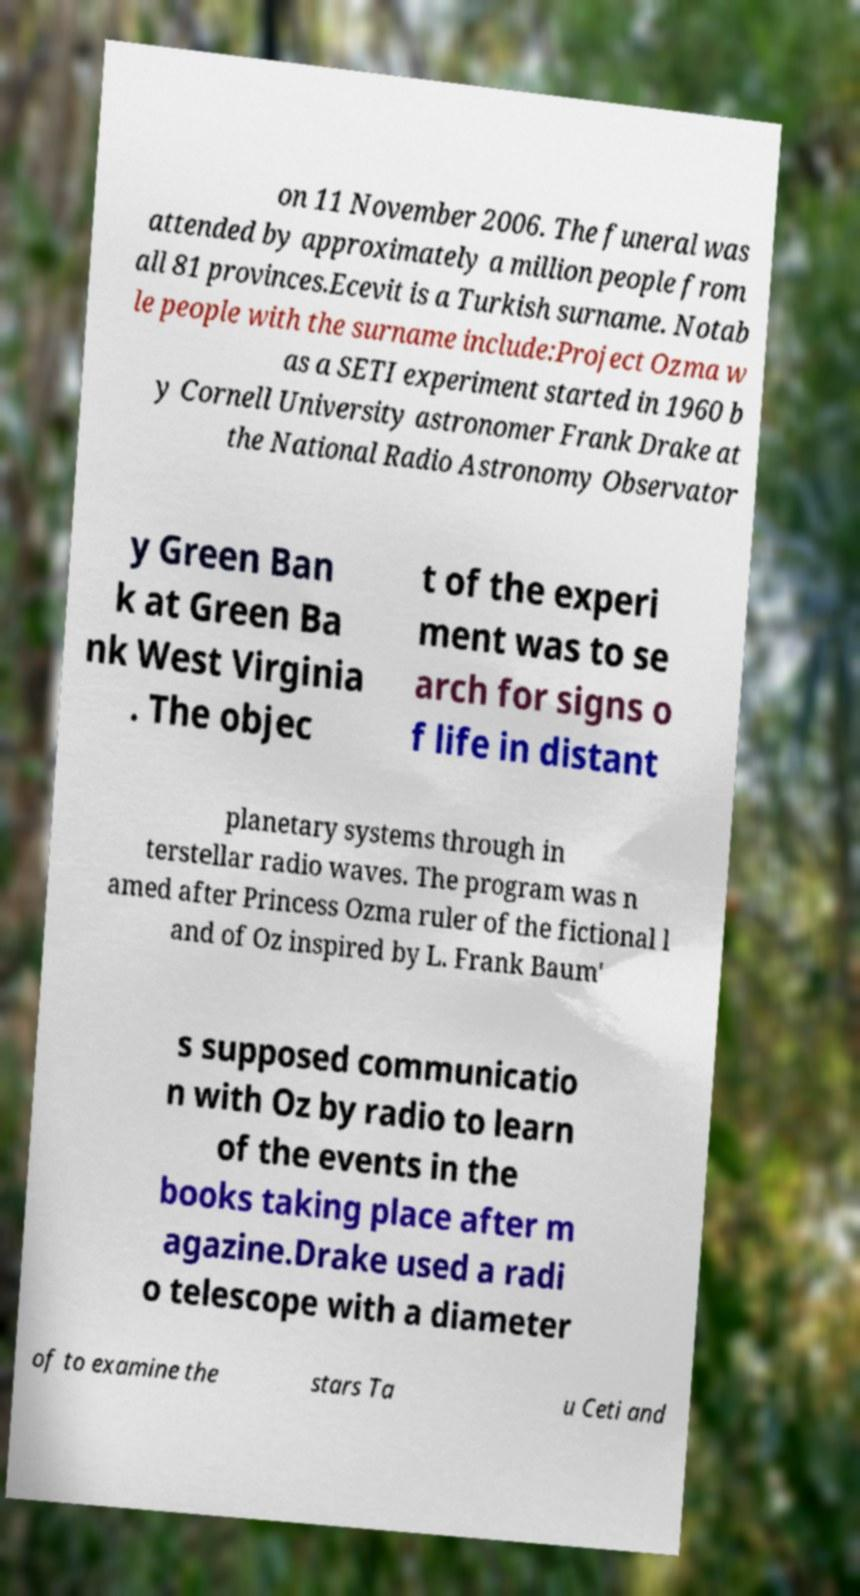Please read and relay the text visible in this image. What does it say? on 11 November 2006. The funeral was attended by approximately a million people from all 81 provinces.Ecevit is a Turkish surname. Notab le people with the surname include:Project Ozma w as a SETI experiment started in 1960 b y Cornell University astronomer Frank Drake at the National Radio Astronomy Observator y Green Ban k at Green Ba nk West Virginia . The objec t of the experi ment was to se arch for signs o f life in distant planetary systems through in terstellar radio waves. The program was n amed after Princess Ozma ruler of the fictional l and of Oz inspired by L. Frank Baum' s supposed communicatio n with Oz by radio to learn of the events in the books taking place after m agazine.Drake used a radi o telescope with a diameter of to examine the stars Ta u Ceti and 